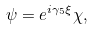Convert formula to latex. <formula><loc_0><loc_0><loc_500><loc_500>\psi = e ^ { i \gamma _ { 5 } \xi } \chi ,</formula> 